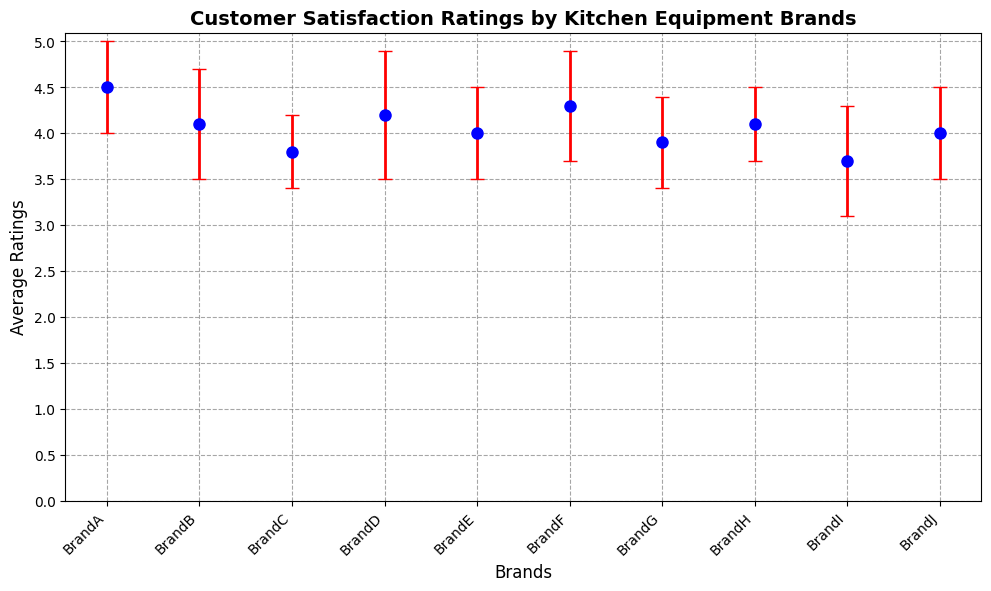What is the highest average customer satisfaction rating among the brands? The highest average rating can be determined by comparing the average ratings of all brands in the chart. BrandA has the highest rating of 4.5.
Answer: 4.5 Which brand has the lowest average customer satisfaction rating? By comparing the average ratings, BrandI has the lowest average customer satisfaction rating of 3.7.
Answer: BrandI Which brand has the highest error bar? The size of the error bar corresponds to the standard deviation, and BrandD has the highest standard deviation of 0.7, making its error bar the largest.
Answer: BrandD What is the range of customer satisfaction ratings across all brands? The highest rating is 4.5 (BrandA) and the lowest is 3.7 (BrandI). The range is calculated as 4.5 - 3.7.
Answer: 0.8 How do the average ratings of BrandB and BrandH compare? Both BrandB and BrandH have an average rating of 4.1, being equivalent.
Answer: Equal Which brand has a smaller error bar, BrandC or BrandE? BrandC has a standard deviation of 0.4, while BrandE has a standard deviation of 0.5. Hence, BrandC has a smaller error bar.
Answer: BrandC What is the combined average rating of BrandA and BrandD? The average rating of BrandA is 4.5 and BrandD is 4.2. The combined average rating is (4.5 + 4.2) / 2 = 4.35.
Answer: 4.35 Considering both average rating and error bars, which brand appears most favorable? BrandA has the highest average rating of 4.5 with a standard deviation of 0.5. Although it has competition in average rating, BrandA’s high rating and reasonable error bar make it the most favorable overall.
Answer: BrandA 